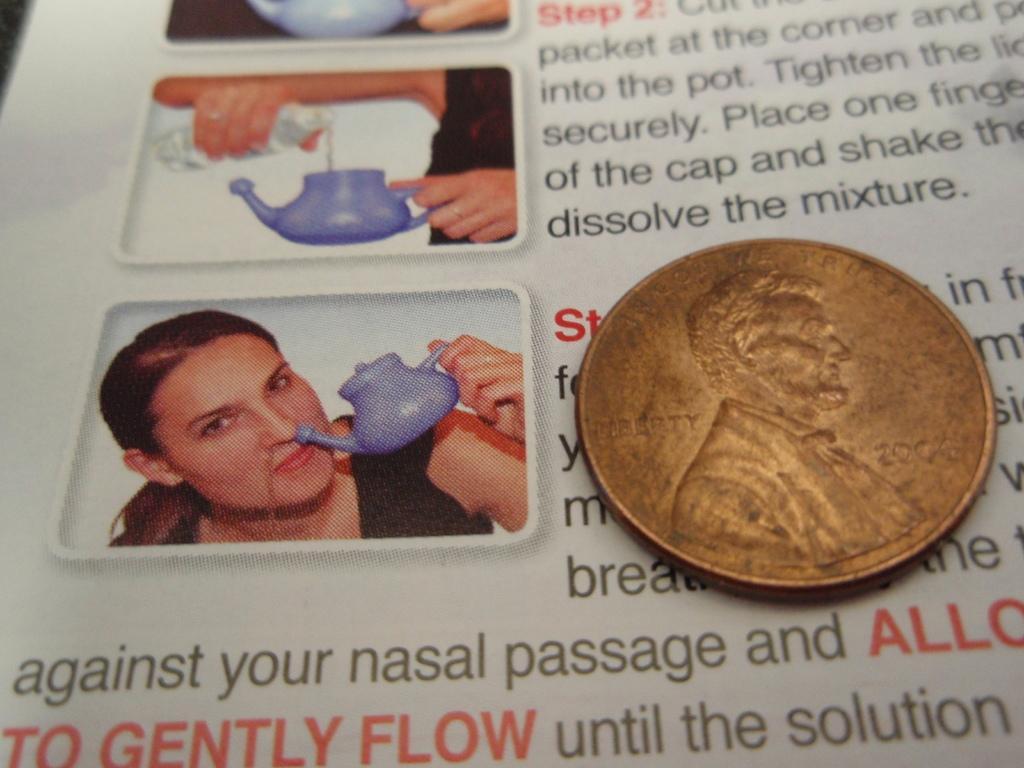In one or two sentences, can you explain what this image depicts? In the image there is a coin kept on a paper with some text and images. 